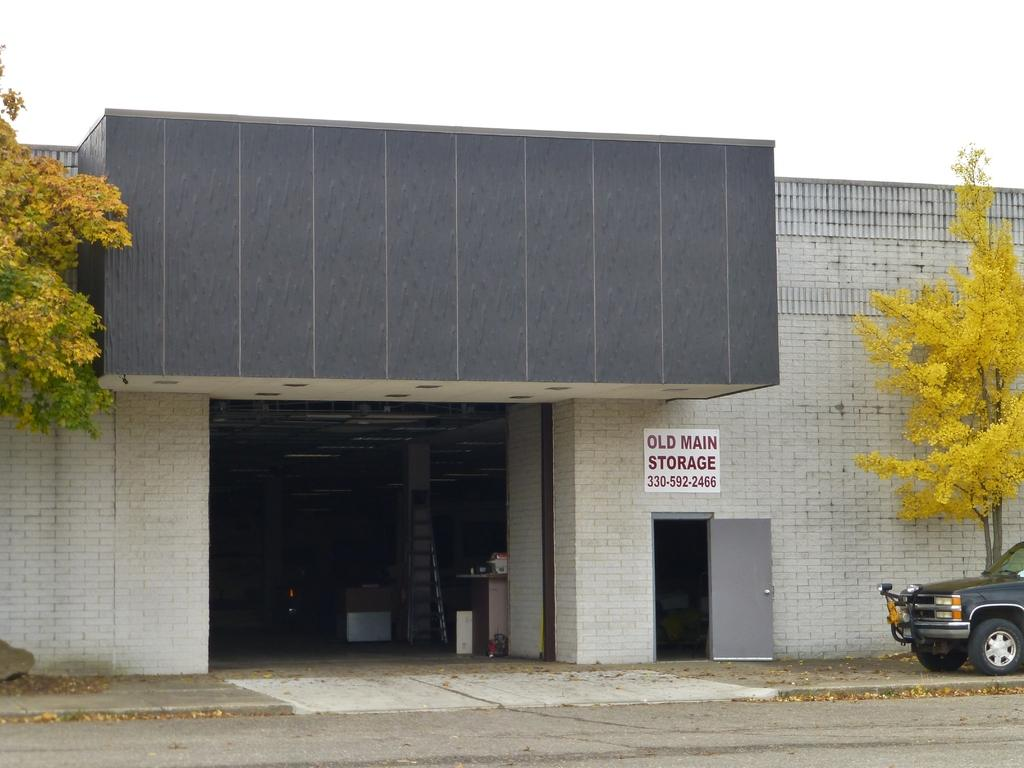What is the main subject in the image? There is a vehicle in the image. What can be seen in the background of the image? There are trees, a building, and the sky in the background of the image. What colors are the leaves on the trees in the background? The leaves in the background are in yellow and green colors. What is the color of the sky in the image? The sky is white in color. Can you see a mountain in the background of the image? There is no mountain present in the image. How does the vehicle comb its hair in the image? Vehicles do not have hair, so they cannot comb it. 